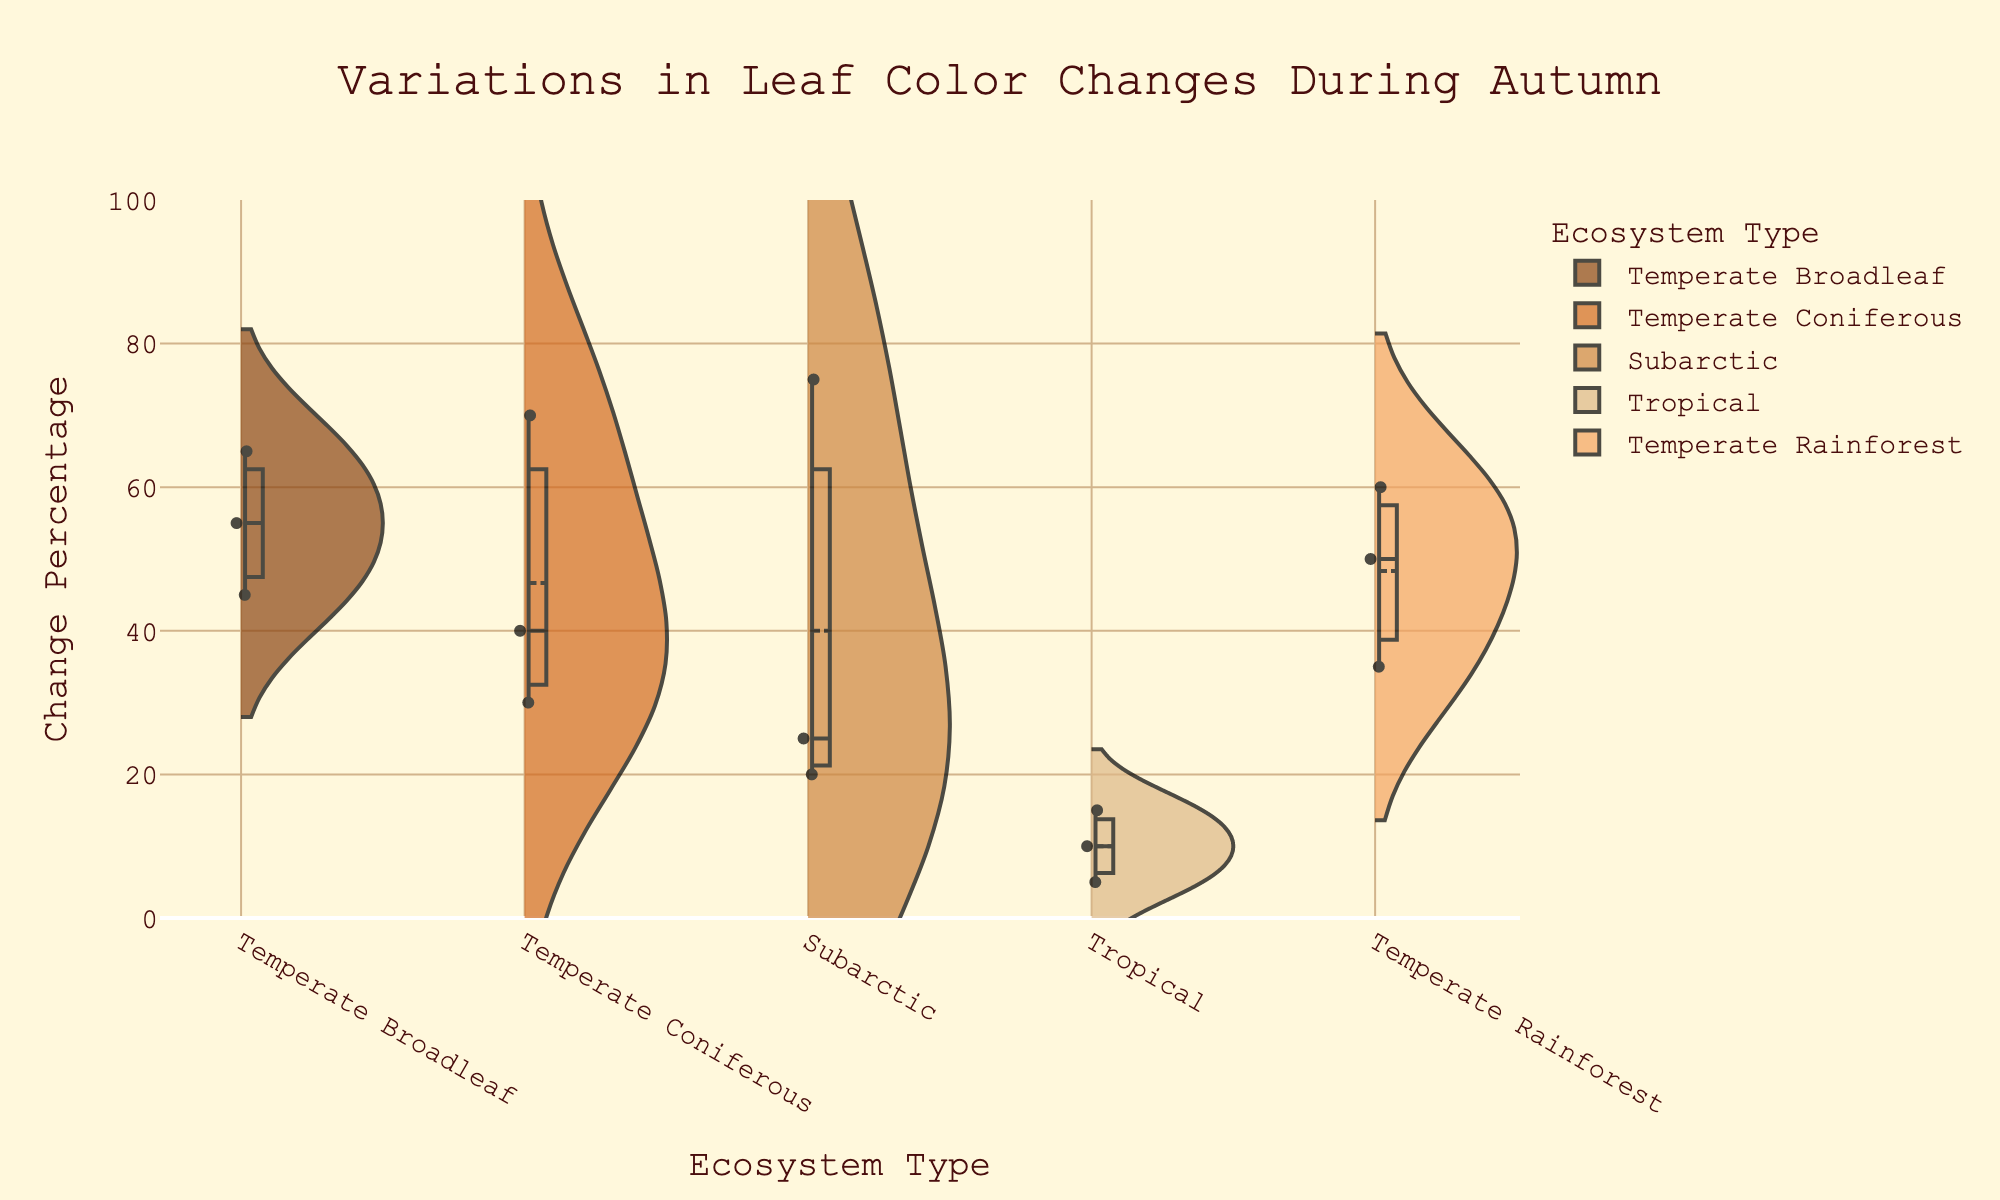What is the title of the figure? The title of the figure is displayed at the top. The words are large and centered.
Answer: Variations in Leaf Color Changes During Autumn What is the y-axis title? The y-axis title is positioned vertically along the y-axis. It indicates the measure being used.
Answer: Change Percentage Which ecosystem type has the highest change percentage? To determine this, find the maximum point on the y-axis and observe which ecosystem type it aligns with.
Answer: Subarctic How many data points are there for the Tropical ecosystem type? Count the individual points in the split violin plot labeled 'Tropical'.
Answer: 3 Which ecosystem type appears to have the least variation in change percentage? Look at the width of the violin plots. Narrower plots indicate less variation.
Answer: Subarctic What is the average change percentage for the Temperate Coniferous ecosystem type? Identify the individual data points for 'Temperate Coniferous': 30, 70, 40. Sum these values and divide by the number of data points: (30 + 70 + 40) / 3 = 46.67
Answer: 46.67 Which week has the highest data point in the Temperate Rainforest ecosystem type? Identify the highest point for 'Temperate Rainforest' and match it to the corresponding week.
Answer: Week 4 Compare the highest change percentage between the Temperate Broadleaf and Subarctic ecosystems. Locate the maximum points for 'Temperate Broadleaf' and 'Subarctic' and compare the values.
Answer: Subarctic is higher Which ecosystem types contain data for Week 1? Identify elements along y-values corresponding to Week 1 and match them to the ecosystem types.
Answer: Subarctic and Tropical How many ecosystem types have a data point with a change percentage higher than 60? Count the number of violin plots with points above the 60% mark on the y-axis.
Answer: 3 